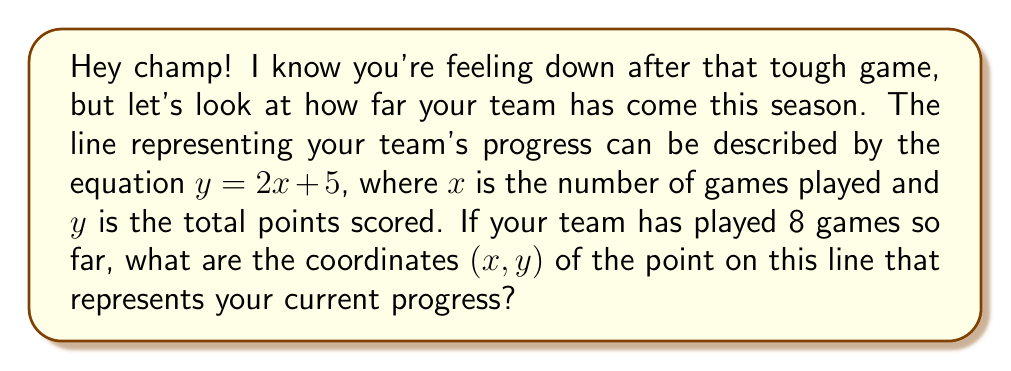Provide a solution to this math problem. Alright, let's break this down step-by-step to see how awesome your team's progress really is:

1) We're given the equation of the line: $y = 2x + 5$

2) We know that $x = 8$ because your team has played 8 games.

3) To find the $y$ coordinate, we need to substitute $x = 8$ into the equation:

   $y = 2(8) + 5$

4) Let's calculate this:
   $y = 16 + 5 = 21$

5) So, after 8 games, your team has scored a total of 21 points. That's impressive!

6) The coordinates of a point are always written as $(x, y)$, so we put our $x$ and $y$ values together.

This point $(8, 21)$ on the line shows exactly where your team stands right now. Look at how far you've come already!
Answer: $(8, 21)$ 